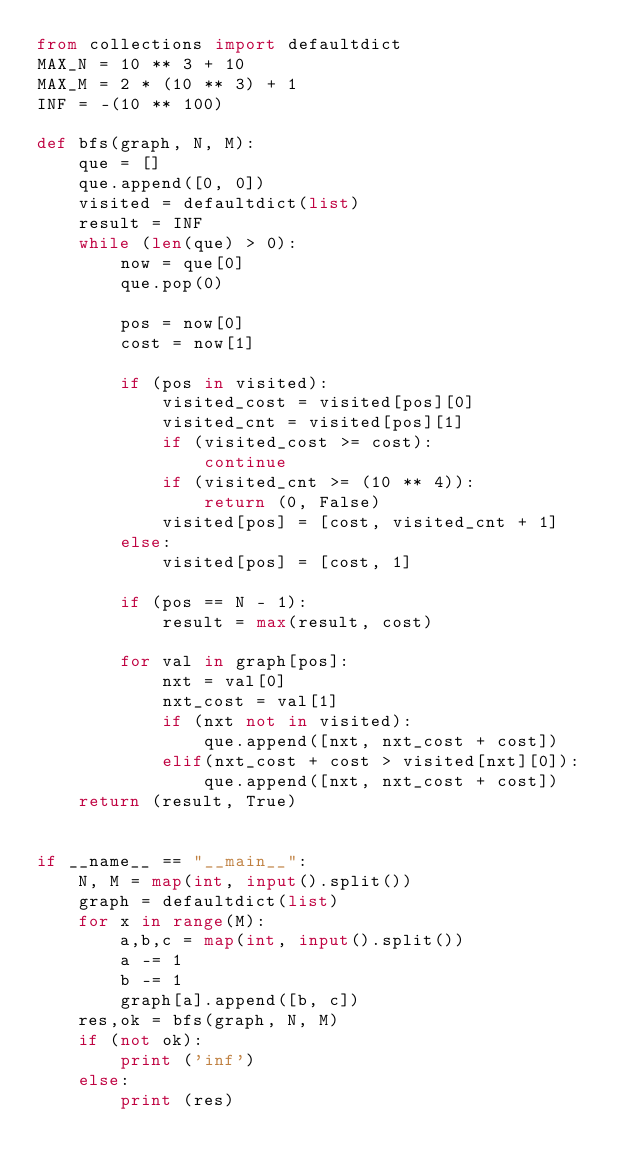<code> <loc_0><loc_0><loc_500><loc_500><_Python_>from collections import defaultdict
MAX_N = 10 ** 3 + 10
MAX_M = 2 * (10 ** 3) + 1
INF = -(10 ** 100)

def bfs(graph, N, M):
    que = []
    que.append([0, 0])
    visited = defaultdict(list)
    result = INF
    while (len(que) > 0):
        now = que[0]
        que.pop(0)

        pos = now[0]
        cost = now[1]

        if (pos in visited):
            visited_cost = visited[pos][0]
            visited_cnt = visited[pos][1]
            if (visited_cost >= cost):
                continue
            if (visited_cnt >= (10 ** 4)):
                return (0, False)
            visited[pos] = [cost, visited_cnt + 1]
        else:
            visited[pos] = [cost, 1]

        if (pos == N - 1):
            result = max(result, cost)

        for val in graph[pos]:
            nxt = val[0]
            nxt_cost = val[1]
            if (nxt not in visited):
                que.append([nxt, nxt_cost + cost])
            elif(nxt_cost + cost > visited[nxt][0]):
                que.append([nxt, nxt_cost + cost])
    return (result, True)


if __name__ == "__main__":
    N, M = map(int, input().split())
    graph = defaultdict(list)
    for x in range(M):
        a,b,c = map(int, input().split())
        a -= 1
        b -= 1
        graph[a].append([b, c])
    res,ok = bfs(graph, N, M)
    if (not ok):
        print ('inf')
    else:
        print (res)
</code> 